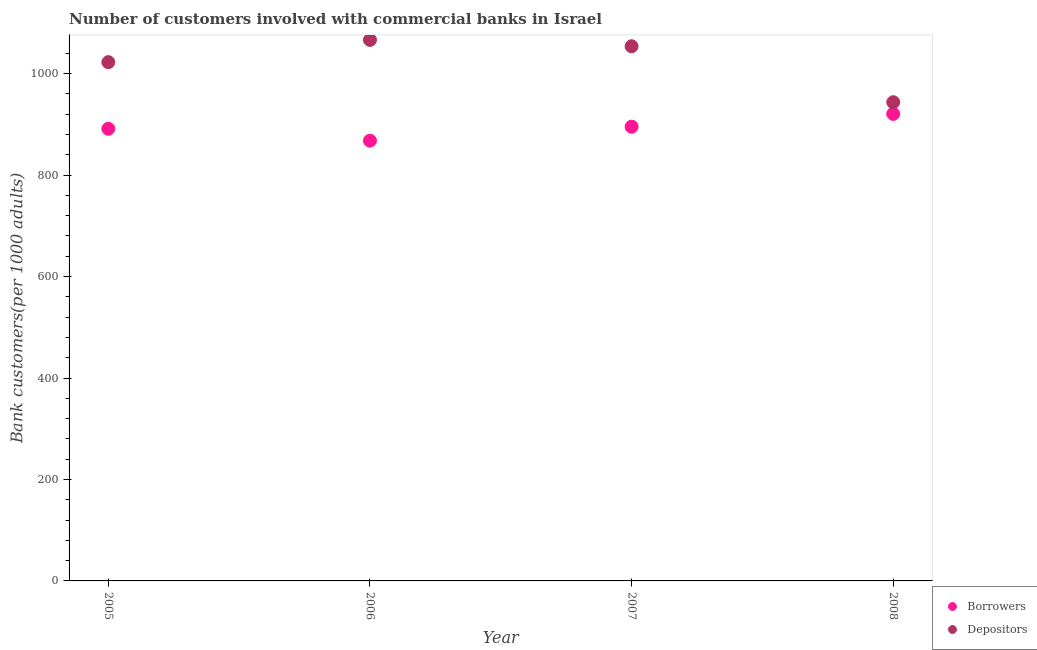How many different coloured dotlines are there?
Offer a terse response. 2. What is the number of depositors in 2006?
Provide a succinct answer. 1066.56. Across all years, what is the maximum number of borrowers?
Your answer should be very brief. 920.77. Across all years, what is the minimum number of borrowers?
Your response must be concise. 867.97. In which year was the number of depositors maximum?
Give a very brief answer. 2006. In which year was the number of borrowers minimum?
Offer a terse response. 2006. What is the total number of borrowers in the graph?
Offer a terse response. 3575.59. What is the difference between the number of borrowers in 2006 and that in 2007?
Give a very brief answer. -27.5. What is the difference between the number of depositors in 2007 and the number of borrowers in 2005?
Offer a very short reply. 162.67. What is the average number of depositors per year?
Ensure brevity in your answer.  1021.76. In the year 2007, what is the difference between the number of borrowers and number of depositors?
Your answer should be compact. -158.59. What is the ratio of the number of borrowers in 2006 to that in 2007?
Your answer should be compact. 0.97. What is the difference between the highest and the second highest number of depositors?
Ensure brevity in your answer.  12.5. What is the difference between the highest and the lowest number of borrowers?
Keep it short and to the point. 52.8. Is the sum of the number of depositors in 2007 and 2008 greater than the maximum number of borrowers across all years?
Make the answer very short. Yes. Is the number of borrowers strictly less than the number of depositors over the years?
Keep it short and to the point. Yes. How many dotlines are there?
Provide a short and direct response. 2. What is the difference between two consecutive major ticks on the Y-axis?
Provide a succinct answer. 200. Does the graph contain any zero values?
Keep it short and to the point. No. Where does the legend appear in the graph?
Your answer should be compact. Bottom right. How are the legend labels stacked?
Provide a succinct answer. Vertical. What is the title of the graph?
Your answer should be very brief. Number of customers involved with commercial banks in Israel. Does "Subsidies" appear as one of the legend labels in the graph?
Keep it short and to the point. No. What is the label or title of the Y-axis?
Your answer should be very brief. Bank customers(per 1000 adults). What is the Bank customers(per 1000 adults) in Borrowers in 2005?
Your answer should be compact. 891.39. What is the Bank customers(per 1000 adults) in Depositors in 2005?
Ensure brevity in your answer.  1022.7. What is the Bank customers(per 1000 adults) in Borrowers in 2006?
Provide a succinct answer. 867.97. What is the Bank customers(per 1000 adults) in Depositors in 2006?
Provide a short and direct response. 1066.56. What is the Bank customers(per 1000 adults) of Borrowers in 2007?
Provide a succinct answer. 895.46. What is the Bank customers(per 1000 adults) in Depositors in 2007?
Your response must be concise. 1054.06. What is the Bank customers(per 1000 adults) in Borrowers in 2008?
Your response must be concise. 920.77. What is the Bank customers(per 1000 adults) in Depositors in 2008?
Offer a very short reply. 943.72. Across all years, what is the maximum Bank customers(per 1000 adults) in Borrowers?
Ensure brevity in your answer.  920.77. Across all years, what is the maximum Bank customers(per 1000 adults) in Depositors?
Offer a terse response. 1066.56. Across all years, what is the minimum Bank customers(per 1000 adults) of Borrowers?
Provide a succinct answer. 867.97. Across all years, what is the minimum Bank customers(per 1000 adults) in Depositors?
Make the answer very short. 943.72. What is the total Bank customers(per 1000 adults) of Borrowers in the graph?
Provide a succinct answer. 3575.59. What is the total Bank customers(per 1000 adults) in Depositors in the graph?
Your answer should be very brief. 4087.04. What is the difference between the Bank customers(per 1000 adults) in Borrowers in 2005 and that in 2006?
Keep it short and to the point. 23.42. What is the difference between the Bank customers(per 1000 adults) of Depositors in 2005 and that in 2006?
Keep it short and to the point. -43.86. What is the difference between the Bank customers(per 1000 adults) in Borrowers in 2005 and that in 2007?
Give a very brief answer. -4.08. What is the difference between the Bank customers(per 1000 adults) of Depositors in 2005 and that in 2007?
Provide a succinct answer. -31.36. What is the difference between the Bank customers(per 1000 adults) in Borrowers in 2005 and that in 2008?
Keep it short and to the point. -29.38. What is the difference between the Bank customers(per 1000 adults) of Depositors in 2005 and that in 2008?
Your answer should be compact. 78.98. What is the difference between the Bank customers(per 1000 adults) in Borrowers in 2006 and that in 2007?
Keep it short and to the point. -27.5. What is the difference between the Bank customers(per 1000 adults) in Depositors in 2006 and that in 2007?
Give a very brief answer. 12.5. What is the difference between the Bank customers(per 1000 adults) in Borrowers in 2006 and that in 2008?
Offer a very short reply. -52.8. What is the difference between the Bank customers(per 1000 adults) in Depositors in 2006 and that in 2008?
Provide a short and direct response. 122.84. What is the difference between the Bank customers(per 1000 adults) of Borrowers in 2007 and that in 2008?
Give a very brief answer. -25.3. What is the difference between the Bank customers(per 1000 adults) in Depositors in 2007 and that in 2008?
Make the answer very short. 110.33. What is the difference between the Bank customers(per 1000 adults) of Borrowers in 2005 and the Bank customers(per 1000 adults) of Depositors in 2006?
Your answer should be very brief. -175.17. What is the difference between the Bank customers(per 1000 adults) in Borrowers in 2005 and the Bank customers(per 1000 adults) in Depositors in 2007?
Give a very brief answer. -162.67. What is the difference between the Bank customers(per 1000 adults) in Borrowers in 2005 and the Bank customers(per 1000 adults) in Depositors in 2008?
Offer a very short reply. -52.34. What is the difference between the Bank customers(per 1000 adults) of Borrowers in 2006 and the Bank customers(per 1000 adults) of Depositors in 2007?
Offer a terse response. -186.09. What is the difference between the Bank customers(per 1000 adults) of Borrowers in 2006 and the Bank customers(per 1000 adults) of Depositors in 2008?
Offer a very short reply. -75.76. What is the difference between the Bank customers(per 1000 adults) in Borrowers in 2007 and the Bank customers(per 1000 adults) in Depositors in 2008?
Your answer should be very brief. -48.26. What is the average Bank customers(per 1000 adults) in Borrowers per year?
Provide a short and direct response. 893.9. What is the average Bank customers(per 1000 adults) in Depositors per year?
Offer a terse response. 1021.76. In the year 2005, what is the difference between the Bank customers(per 1000 adults) of Borrowers and Bank customers(per 1000 adults) of Depositors?
Ensure brevity in your answer.  -131.31. In the year 2006, what is the difference between the Bank customers(per 1000 adults) in Borrowers and Bank customers(per 1000 adults) in Depositors?
Make the answer very short. -198.6. In the year 2007, what is the difference between the Bank customers(per 1000 adults) in Borrowers and Bank customers(per 1000 adults) in Depositors?
Offer a very short reply. -158.59. In the year 2008, what is the difference between the Bank customers(per 1000 adults) in Borrowers and Bank customers(per 1000 adults) in Depositors?
Keep it short and to the point. -22.96. What is the ratio of the Bank customers(per 1000 adults) in Depositors in 2005 to that in 2006?
Keep it short and to the point. 0.96. What is the ratio of the Bank customers(per 1000 adults) in Borrowers in 2005 to that in 2007?
Give a very brief answer. 1. What is the ratio of the Bank customers(per 1000 adults) of Depositors in 2005 to that in 2007?
Your answer should be compact. 0.97. What is the ratio of the Bank customers(per 1000 adults) of Borrowers in 2005 to that in 2008?
Provide a short and direct response. 0.97. What is the ratio of the Bank customers(per 1000 adults) in Depositors in 2005 to that in 2008?
Give a very brief answer. 1.08. What is the ratio of the Bank customers(per 1000 adults) of Borrowers in 2006 to that in 2007?
Give a very brief answer. 0.97. What is the ratio of the Bank customers(per 1000 adults) of Depositors in 2006 to that in 2007?
Offer a very short reply. 1.01. What is the ratio of the Bank customers(per 1000 adults) of Borrowers in 2006 to that in 2008?
Provide a succinct answer. 0.94. What is the ratio of the Bank customers(per 1000 adults) of Depositors in 2006 to that in 2008?
Offer a very short reply. 1.13. What is the ratio of the Bank customers(per 1000 adults) in Borrowers in 2007 to that in 2008?
Your answer should be compact. 0.97. What is the ratio of the Bank customers(per 1000 adults) in Depositors in 2007 to that in 2008?
Offer a very short reply. 1.12. What is the difference between the highest and the second highest Bank customers(per 1000 adults) in Borrowers?
Offer a terse response. 25.3. What is the difference between the highest and the second highest Bank customers(per 1000 adults) of Depositors?
Offer a terse response. 12.5. What is the difference between the highest and the lowest Bank customers(per 1000 adults) in Borrowers?
Your answer should be compact. 52.8. What is the difference between the highest and the lowest Bank customers(per 1000 adults) in Depositors?
Keep it short and to the point. 122.84. 